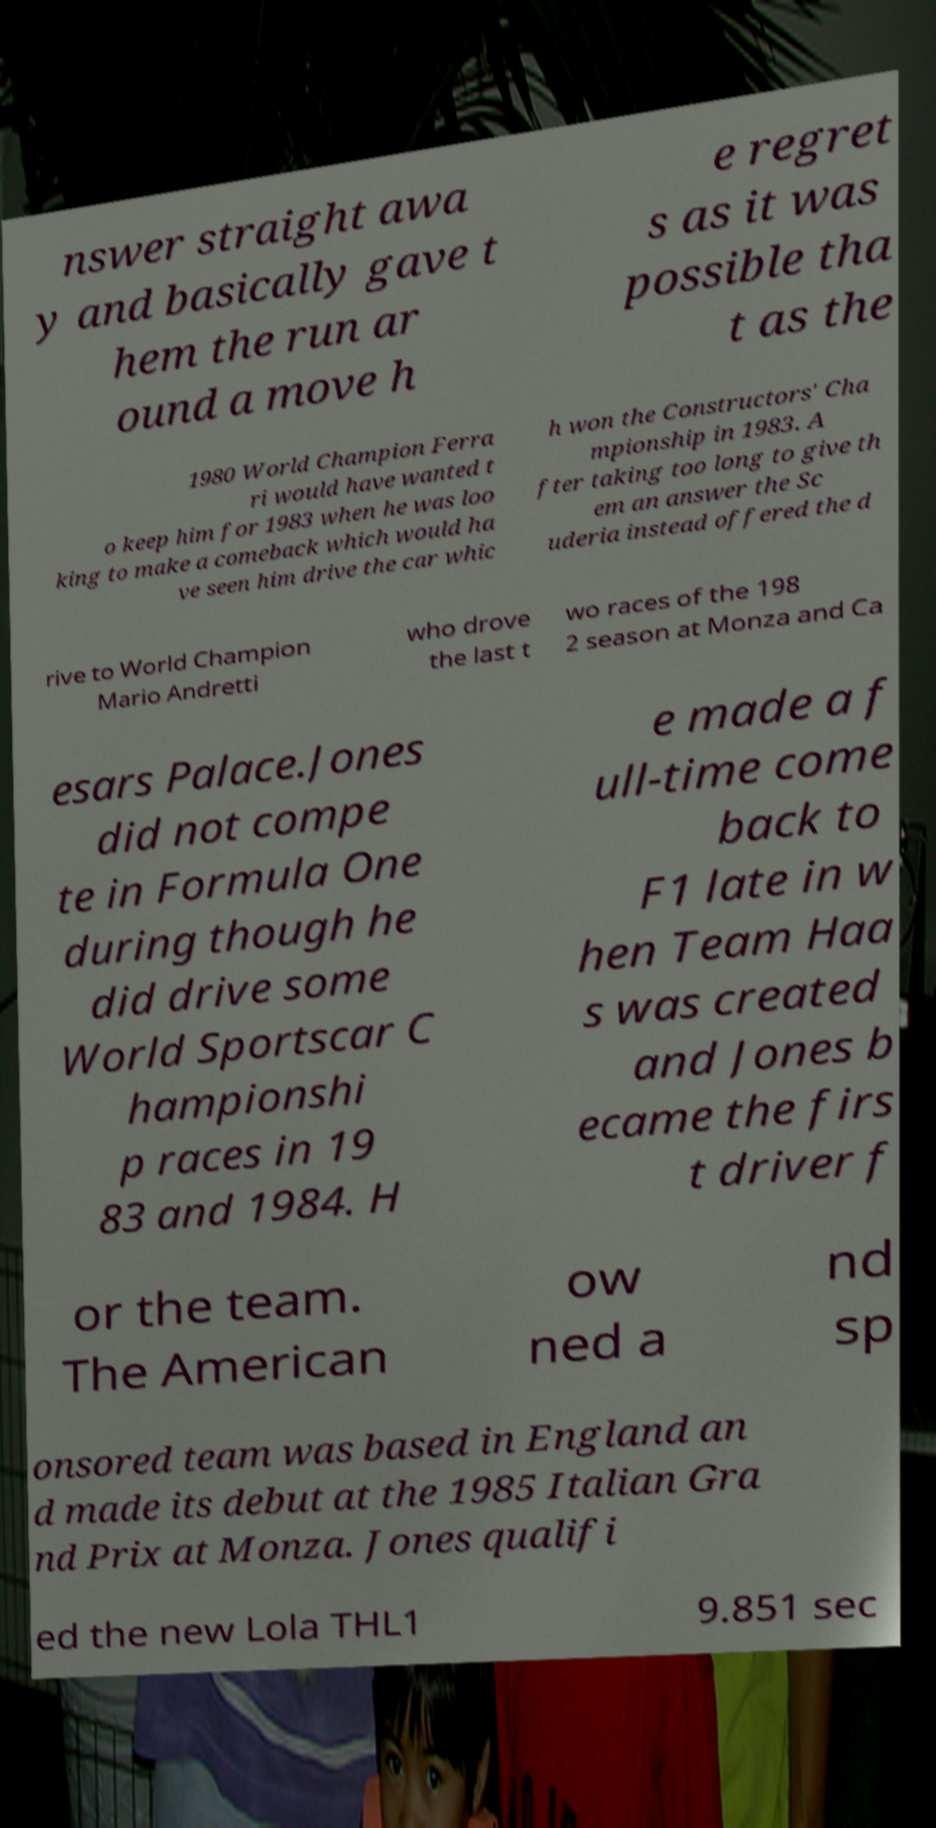Could you assist in decoding the text presented in this image and type it out clearly? nswer straight awa y and basically gave t hem the run ar ound a move h e regret s as it was possible tha t as the 1980 World Champion Ferra ri would have wanted t o keep him for 1983 when he was loo king to make a comeback which would ha ve seen him drive the car whic h won the Constructors' Cha mpionship in 1983. A fter taking too long to give th em an answer the Sc uderia instead offered the d rive to World Champion Mario Andretti who drove the last t wo races of the 198 2 season at Monza and Ca esars Palace.Jones did not compe te in Formula One during though he did drive some World Sportscar C hampionshi p races in 19 83 and 1984. H e made a f ull-time come back to F1 late in w hen Team Haa s was created and Jones b ecame the firs t driver f or the team. The American ow ned a nd sp onsored team was based in England an d made its debut at the 1985 Italian Gra nd Prix at Monza. Jones qualifi ed the new Lola THL1 9.851 sec 